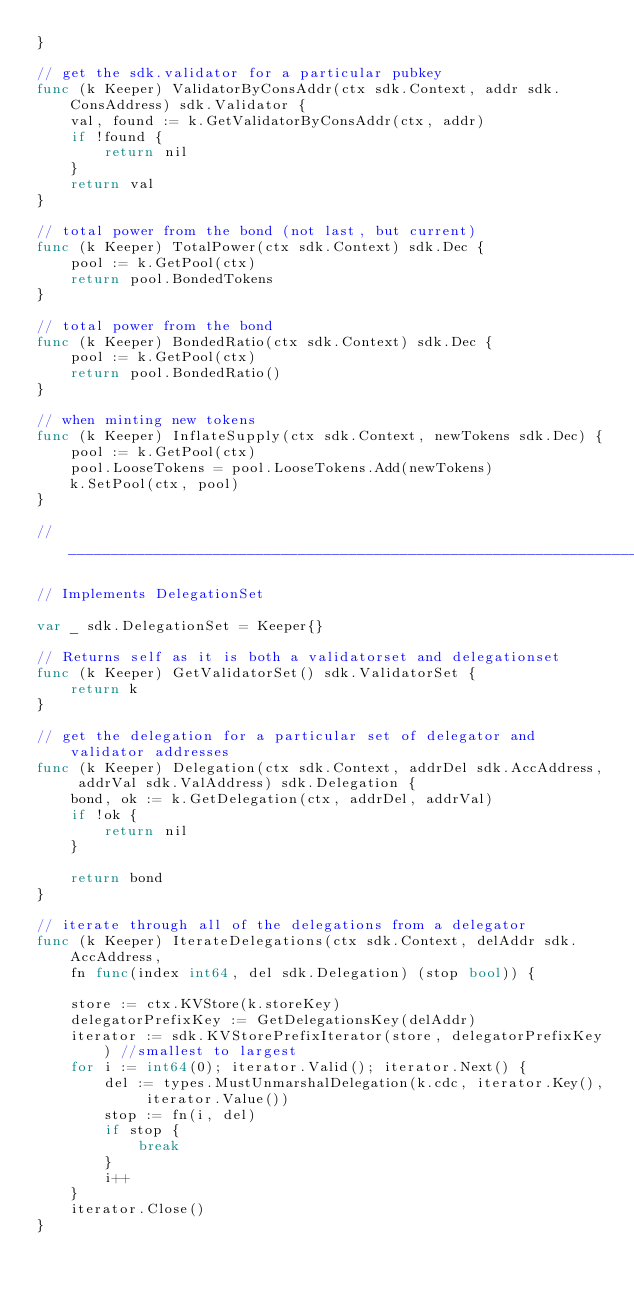<code> <loc_0><loc_0><loc_500><loc_500><_Go_>}

// get the sdk.validator for a particular pubkey
func (k Keeper) ValidatorByConsAddr(ctx sdk.Context, addr sdk.ConsAddress) sdk.Validator {
	val, found := k.GetValidatorByConsAddr(ctx, addr)
	if !found {
		return nil
	}
	return val
}

// total power from the bond (not last, but current)
func (k Keeper) TotalPower(ctx sdk.Context) sdk.Dec {
	pool := k.GetPool(ctx)
	return pool.BondedTokens
}

// total power from the bond
func (k Keeper) BondedRatio(ctx sdk.Context) sdk.Dec {
	pool := k.GetPool(ctx)
	return pool.BondedRatio()
}

// when minting new tokens
func (k Keeper) InflateSupply(ctx sdk.Context, newTokens sdk.Dec) {
	pool := k.GetPool(ctx)
	pool.LooseTokens = pool.LooseTokens.Add(newTokens)
	k.SetPool(ctx, pool)
}

//__________________________________________________________________________

// Implements DelegationSet

var _ sdk.DelegationSet = Keeper{}

// Returns self as it is both a validatorset and delegationset
func (k Keeper) GetValidatorSet() sdk.ValidatorSet {
	return k
}

// get the delegation for a particular set of delegator and validator addresses
func (k Keeper) Delegation(ctx sdk.Context, addrDel sdk.AccAddress, addrVal sdk.ValAddress) sdk.Delegation {
	bond, ok := k.GetDelegation(ctx, addrDel, addrVal)
	if !ok {
		return nil
	}

	return bond
}

// iterate through all of the delegations from a delegator
func (k Keeper) IterateDelegations(ctx sdk.Context, delAddr sdk.AccAddress,
	fn func(index int64, del sdk.Delegation) (stop bool)) {

	store := ctx.KVStore(k.storeKey)
	delegatorPrefixKey := GetDelegationsKey(delAddr)
	iterator := sdk.KVStorePrefixIterator(store, delegatorPrefixKey) //smallest to largest
	for i := int64(0); iterator.Valid(); iterator.Next() {
		del := types.MustUnmarshalDelegation(k.cdc, iterator.Key(), iterator.Value())
		stop := fn(i, del)
		if stop {
			break
		}
		i++
	}
	iterator.Close()
}
</code> 